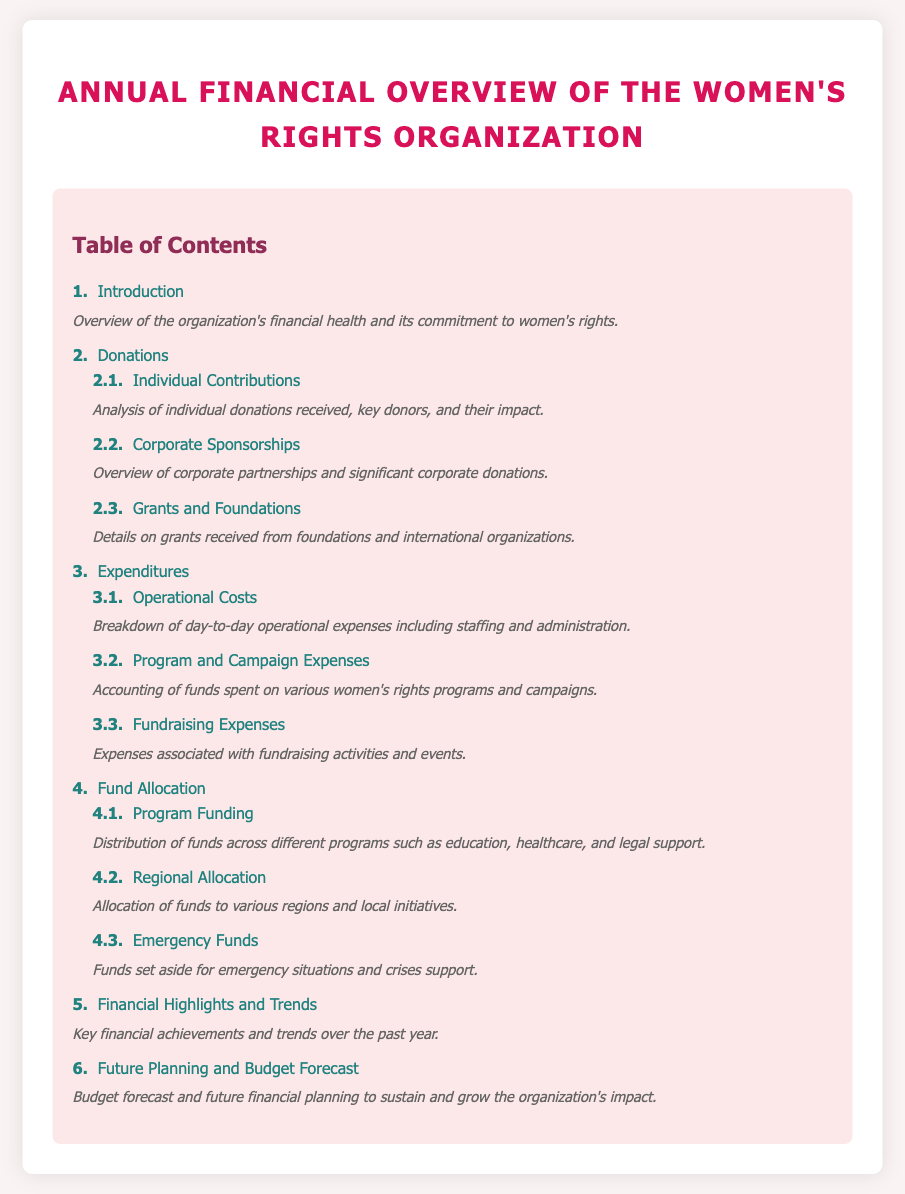what is the first section title? The first section in the table of contents is about the introduction of the organization's financial health.
Answer: Introduction how many subsections are under Donations? The Donations section includes three subsections that deal with individual contributions, corporate sponsorships, and grants.
Answer: 3 what does the Fund Allocation section cover? The Fund Allocation section addresses how funds are distributed across different programs, regional allocations, and emergency funds.
Answer: Distribution of funds which section outlines operational expenses? The section that provides a breakdown of day-to-day operational expenses is the Expenditures section, specifically the Operational Costs subsection.
Answer: Expenditures what is one focus area of Program Funding? The Program Funding focuses on areas such as education, healthcare, and legal support.
Answer: Education what are the last two sections in the table of contents? The last two sections address financial highlights and future planning related to the organization's budget.
Answer: Financial Highlights and Trends, Future Planning and Budget Forecast how many items are listed in the Fund Allocation subsection? There are three items listed under the Fund Allocation subsection: Program Funding, Regional Allocation, and Emergency Funds.
Answer: 3 what type of information does the section on Financial Highlights and Trends provide? This section reviews key achievements and trends regarding the organization's finances over the past year.
Answer: Financial achievements what can be inferred about the organization's financial health from the Introduction section? The Introduction provides an overview of the organization’s financial health and commitment to women's rights, indicating overall positivity and dedication.
Answer: Positive commitment 